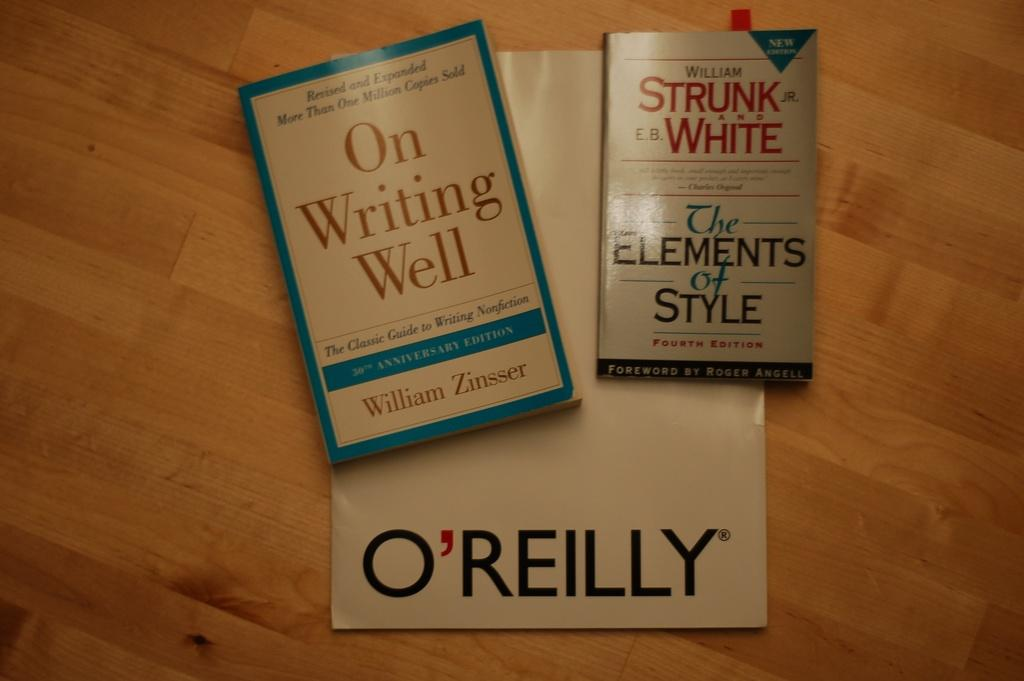<image>
Give a short and clear explanation of the subsequent image. Two books sit on a table, and under them sits a piece of paper with the name O'Reilly. 